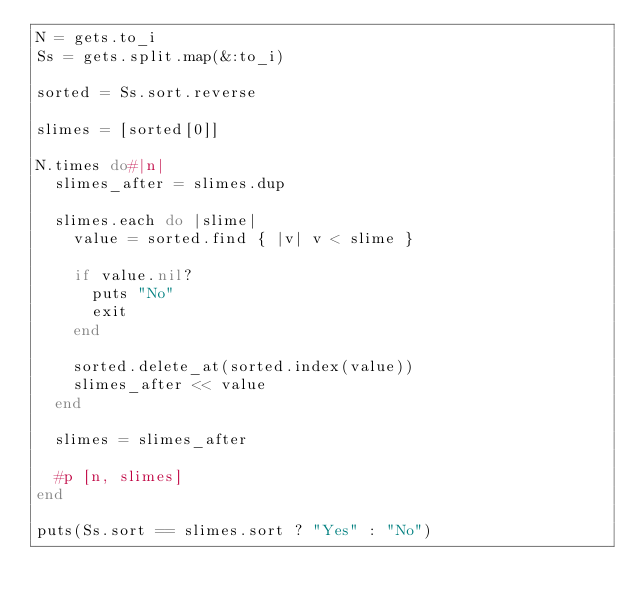<code> <loc_0><loc_0><loc_500><loc_500><_Ruby_>N = gets.to_i
Ss = gets.split.map(&:to_i)

sorted = Ss.sort.reverse

slimes = [sorted[0]]

N.times do#|n|
  slimes_after = slimes.dup

  slimes.each do |slime|
    value = sorted.find { |v| v < slime }

    if value.nil?
      puts "No"
      exit
    end

    sorted.delete_at(sorted.index(value))
    slimes_after << value
  end

  slimes = slimes_after

  #p [n, slimes]
end

puts(Ss.sort == slimes.sort ? "Yes" : "No")
</code> 